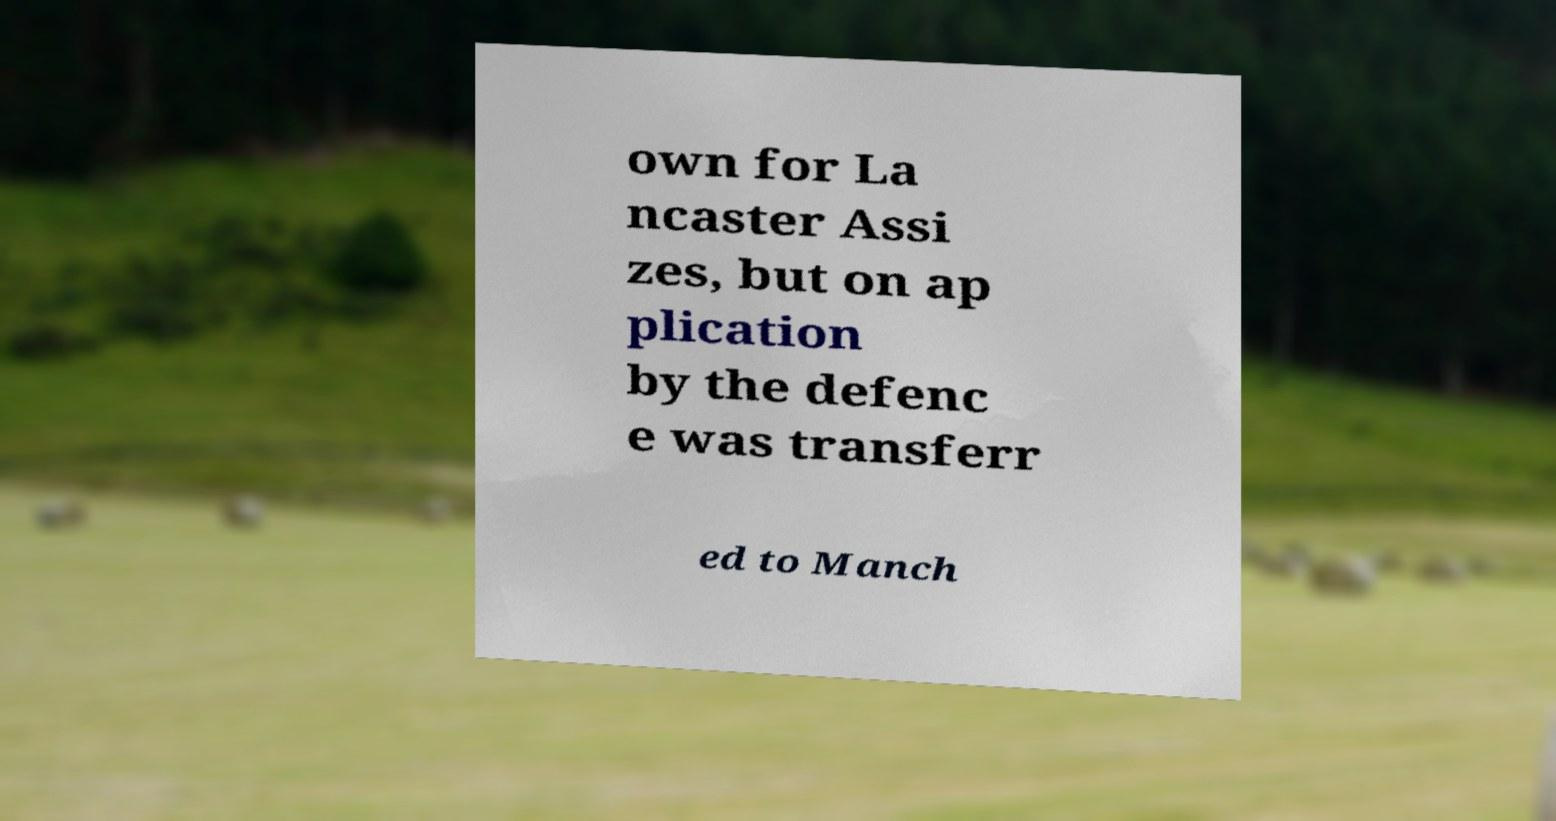Can you read and provide the text displayed in the image?This photo seems to have some interesting text. Can you extract and type it out for me? own for La ncaster Assi zes, but on ap plication by the defenc e was transferr ed to Manch 